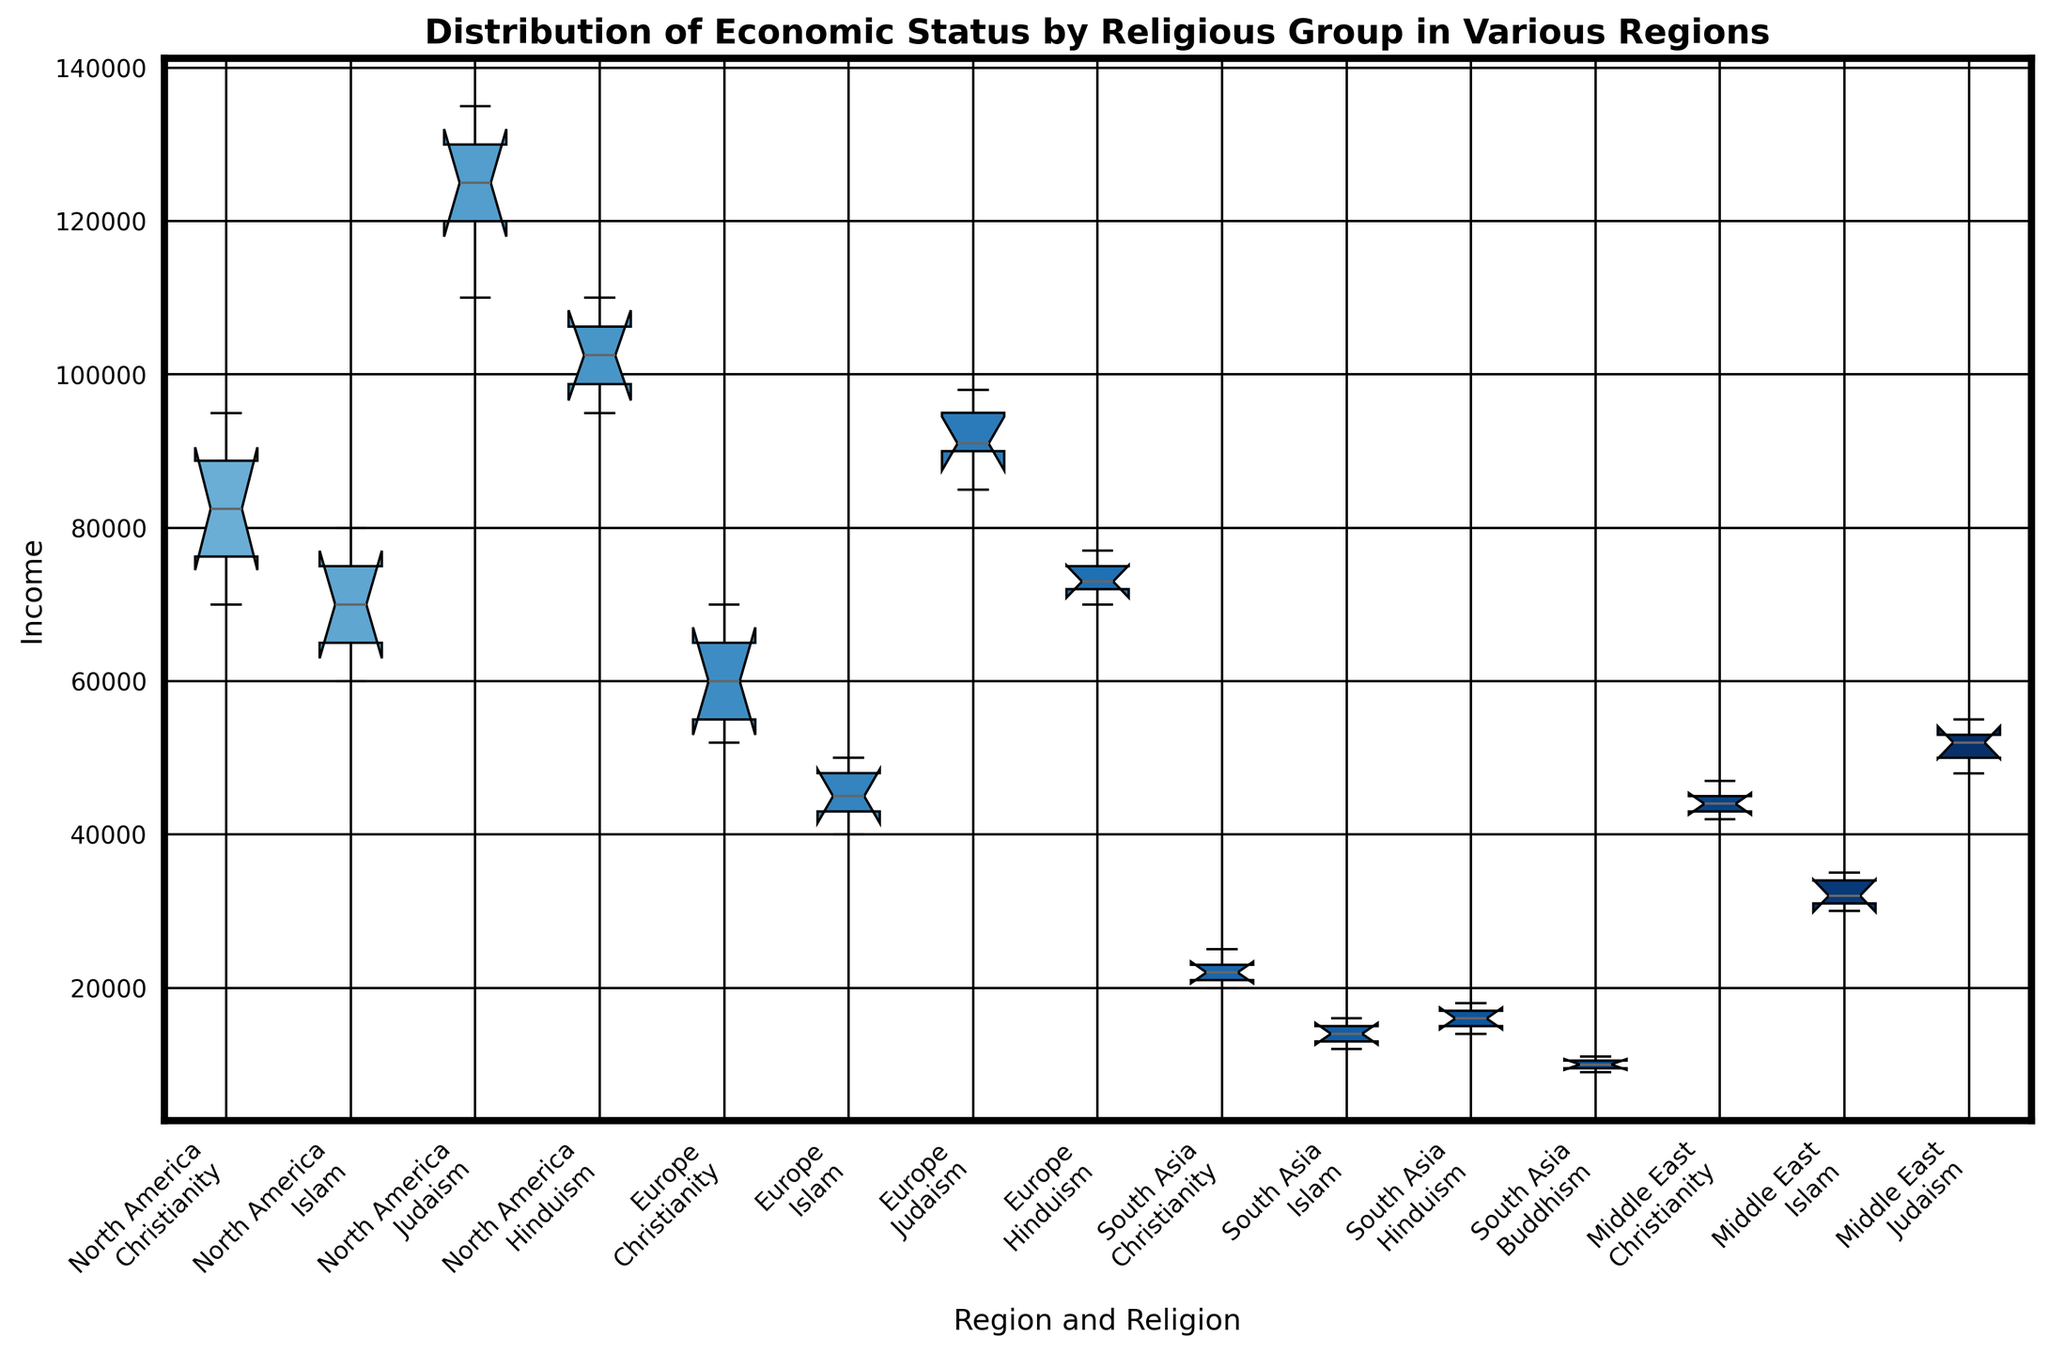What's the median income of Christianity in Europe? To find the median income for Christianity in Europe, first list the incomes in ascending order: 52000, 55000, 60000, 65000, 70000. With five values, the median is the middle value, which is 60000.
Answer: 60000 Which religious group has the highest median income overall? To determine the group with the highest median income overall, compare the medians of all religious groups across regions. For example, North America's Judaism has a median of 125000, which is higher than other groups.
Answer: Judaism in North America In the Middle East, do Christians have higher or lower median income compared to Muslims? In the Middle East, the median income for Christianity (42000, 43000, 44000, 45000, 47000) is 44000. For Islam (30000, 31000, 32000, 34000, 35000), the median is 32000. Comparing the two medians, Christians have a higher median income than Muslims.
Answer: Higher What is the income range of Hinduism in South Asia? The income range is found by subtracting the minimum value from the maximum value in the group. For Hinduism in South Asia, the incomes are 14000, 15000, 16000, 17000, 18000. Thus, the range is 18000 - 14000 = 4000.
Answer: 4000 Which region-religion combination shows the smallest interquartile range (IQR) and what is the value? Calculate IQR for each combination and find the smallest. For instance, Hinduism in Europe has incomes: 70000, 72000, 73000, 75000, 77000. It has an IQR of Q3-Q1 = 75000-72000 = 3000. Compare all IQRs to find the minimum.
Answer: Hinduism in Europe, 3000 How does the income distribution for Islam in North America compare visually to Judaism in Europe? Visually compare the two box plots. Islam in North America shows less spread (narrower box) and lower overall values than Judaism in Europe. Judaism in Europe has higher outliers and a higher median.
Answer: Judaism in Europe is higher and more spread What is the 75th percentile income for Judaism in the Middle East? The 75th percentile (Q3) is found by arranging the incomes in ascending order and taking the value at the 75th percentile position. For Judaism in the Middle East: 48000, 50000, 52000, 53000, 55000. Q3 is 53000.
Answer: 53000 Does any religious group in any region have overlapping income ranges with another group in the same region? Examine overlap in box plots. For example, Christianity and Islam in North America overlap as Christianity ranges approximately from 70000 to 95000 and Islam from 60000 to 80000.
Answer: Yes 